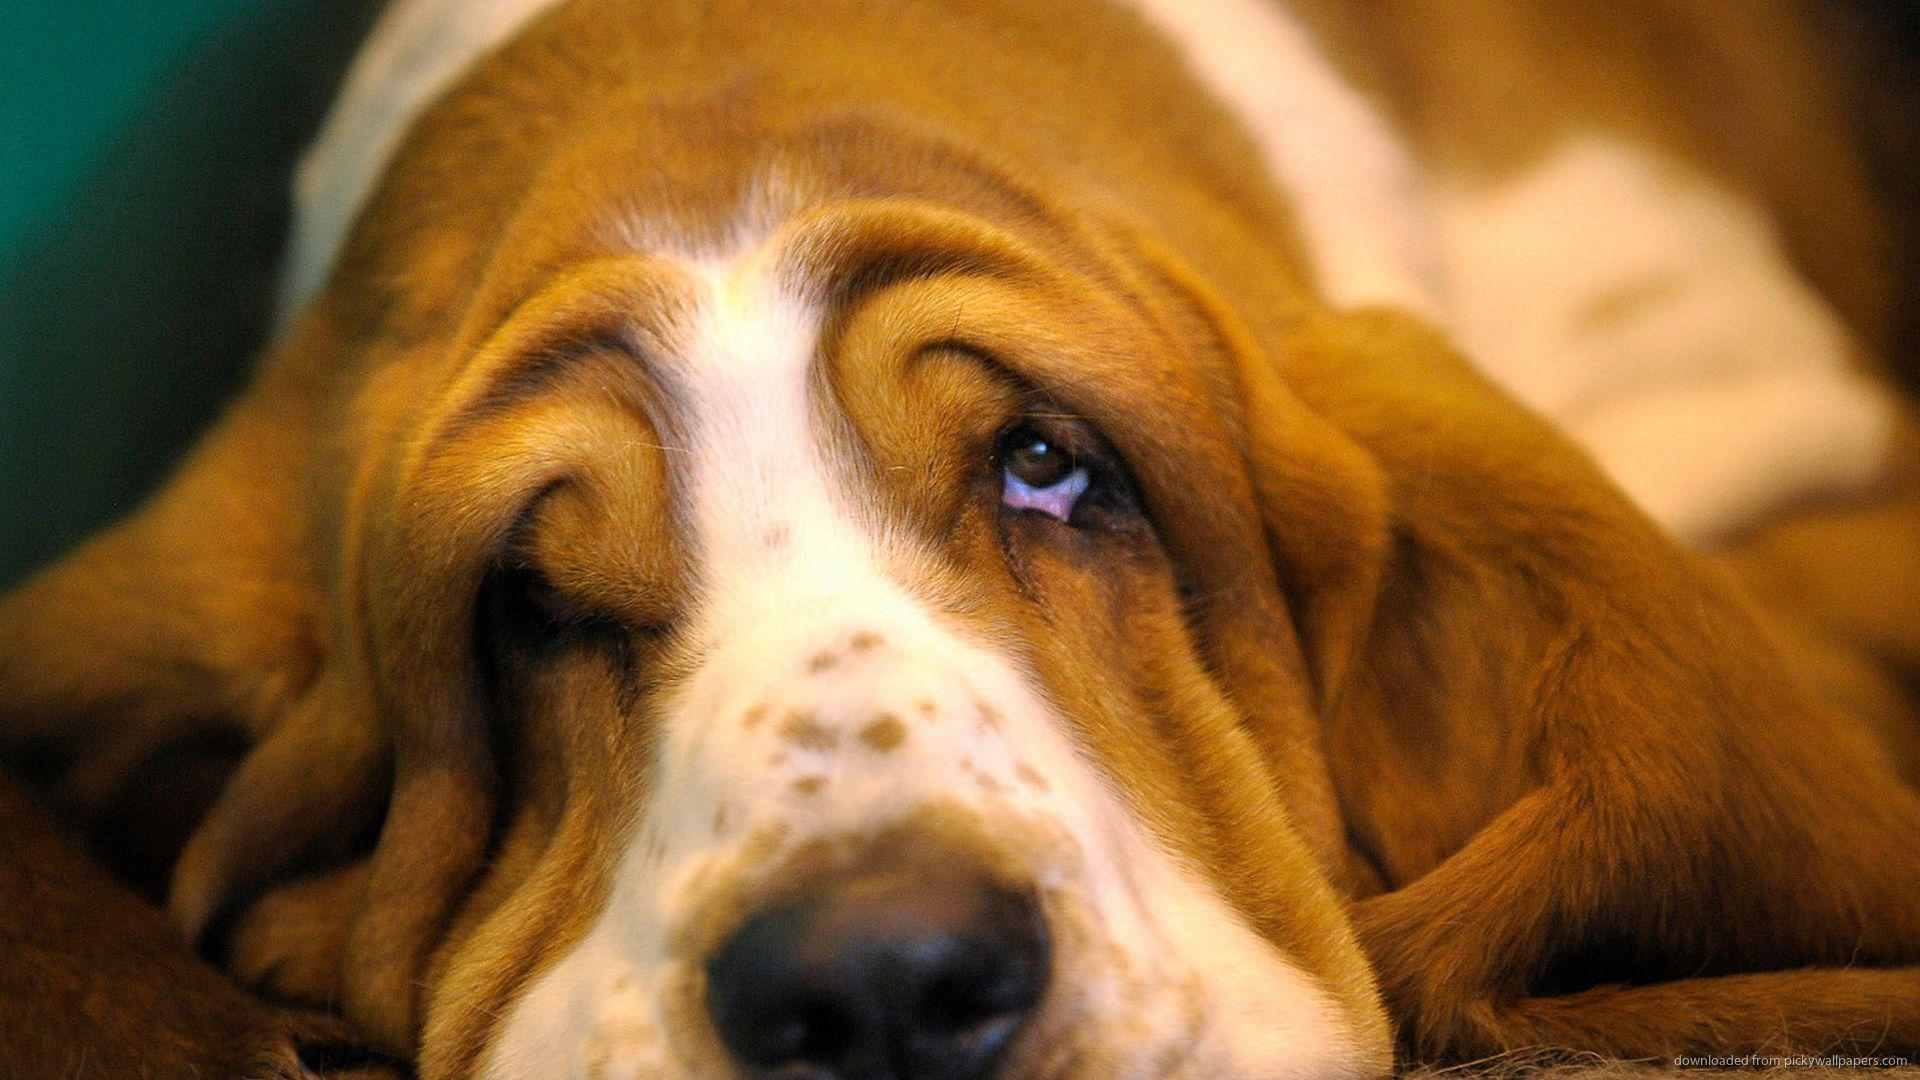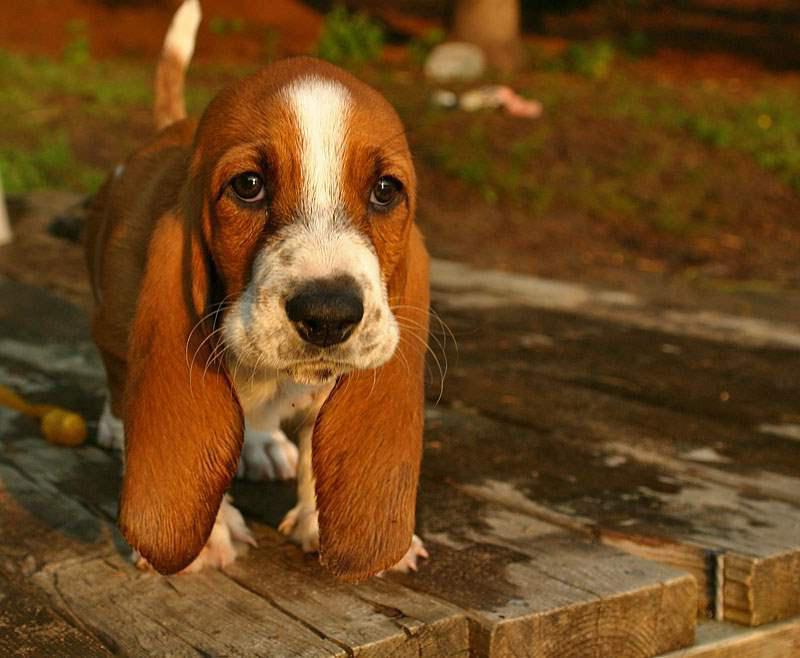The first image is the image on the left, the second image is the image on the right. Evaluate the accuracy of this statement regarding the images: "One image features a basset pup on a wood plank deck outdoors.". Is it true? Answer yes or no. Yes. The first image is the image on the left, the second image is the image on the right. Assess this claim about the two images: "the dog's tail is visible in one of the images". Correct or not? Answer yes or no. Yes. 